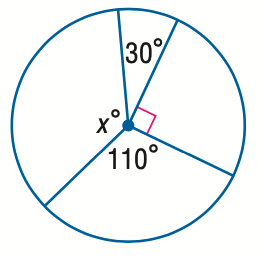Question: Find the value of x.
Choices:
A. 30
B. 90
C. 110
D. 130
Answer with the letter. Answer: D 